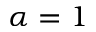<formula> <loc_0><loc_0><loc_500><loc_500>\alpha = 1</formula> 